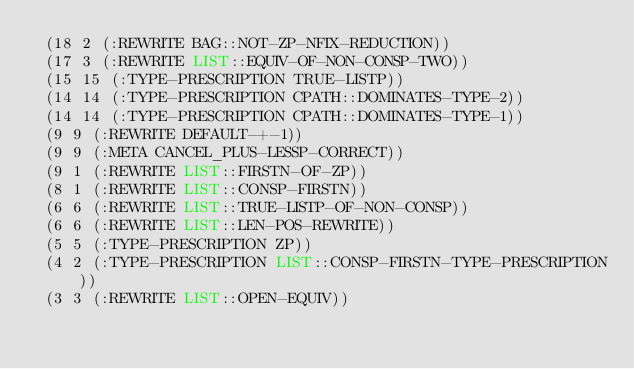<code> <loc_0><loc_0><loc_500><loc_500><_Lisp_> (18 2 (:REWRITE BAG::NOT-ZP-NFIX-REDUCTION))
 (17 3 (:REWRITE LIST::EQUIV-OF-NON-CONSP-TWO))
 (15 15 (:TYPE-PRESCRIPTION TRUE-LISTP))
 (14 14 (:TYPE-PRESCRIPTION CPATH::DOMINATES-TYPE-2))
 (14 14 (:TYPE-PRESCRIPTION CPATH::DOMINATES-TYPE-1))
 (9 9 (:REWRITE DEFAULT-+-1))
 (9 9 (:META CANCEL_PLUS-LESSP-CORRECT))
 (9 1 (:REWRITE LIST::FIRSTN-OF-ZP))
 (8 1 (:REWRITE LIST::CONSP-FIRSTN))
 (6 6 (:REWRITE LIST::TRUE-LISTP-OF-NON-CONSP))
 (6 6 (:REWRITE LIST::LEN-POS-REWRITE))
 (5 5 (:TYPE-PRESCRIPTION ZP))
 (4 2 (:TYPE-PRESCRIPTION LIST::CONSP-FIRSTN-TYPE-PRESCRIPTION))
 (3 3 (:REWRITE LIST::OPEN-EQUIV))</code> 